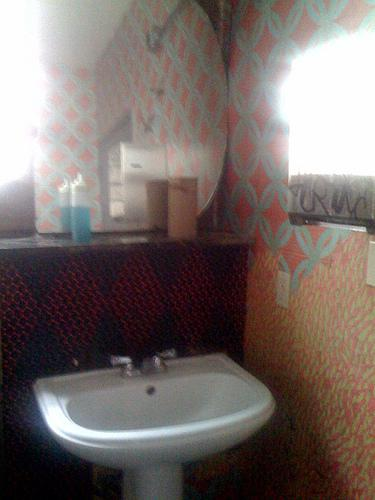Question: who uses the bathroom?
Choices:
A. A man.
B. A child.
C. An elderly person.
D. A woman.
Answer with the letter. Answer: D Question: when was this picture taken?
Choices:
A. Night time.
B. Day time.
C. Long ago.
D. In the winter.
Answer with the letter. Answer: B Question: where was the location?
Choices:
A. Outside.
B. City.
C. Street.
D. Bathroom.
Answer with the letter. Answer: D Question: why is there a mirror?
Choices:
A. To see yourself.
B. To look at your back.
C. To look at reflection.
D. To see your feet.
Answer with the letter. Answer: C 